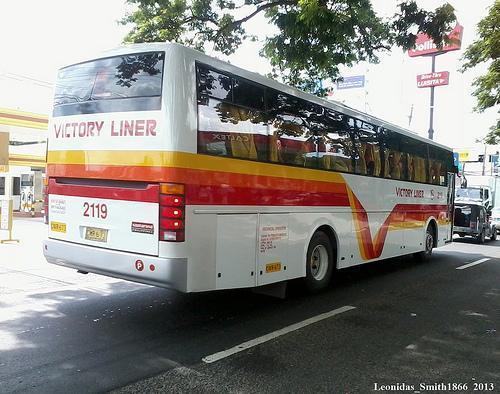How many buses are in the picture?
Give a very brief answer. 1. 